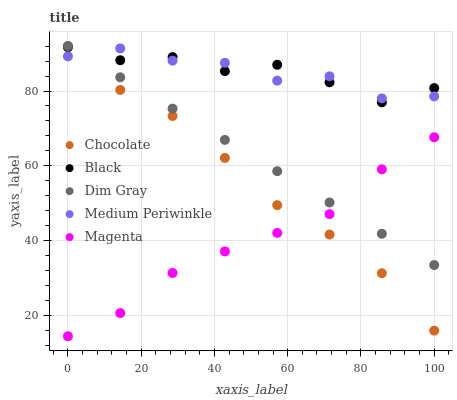Does Magenta have the minimum area under the curve?
Answer yes or no. Yes. Does Medium Periwinkle have the maximum area under the curve?
Answer yes or no. Yes. Does Dim Gray have the minimum area under the curve?
Answer yes or no. No. Does Dim Gray have the maximum area under the curve?
Answer yes or no. No. Is Dim Gray the smoothest?
Answer yes or no. Yes. Is Medium Periwinkle the roughest?
Answer yes or no. Yes. Is Magenta the smoothest?
Answer yes or no. No. Is Magenta the roughest?
Answer yes or no. No. Does Magenta have the lowest value?
Answer yes or no. Yes. Does Dim Gray have the lowest value?
Answer yes or no. No. Does Chocolate have the highest value?
Answer yes or no. Yes. Does Magenta have the highest value?
Answer yes or no. No. Is Magenta less than Medium Periwinkle?
Answer yes or no. Yes. Is Medium Periwinkle greater than Magenta?
Answer yes or no. Yes. Does Chocolate intersect Magenta?
Answer yes or no. Yes. Is Chocolate less than Magenta?
Answer yes or no. No. Is Chocolate greater than Magenta?
Answer yes or no. No. Does Magenta intersect Medium Periwinkle?
Answer yes or no. No. 